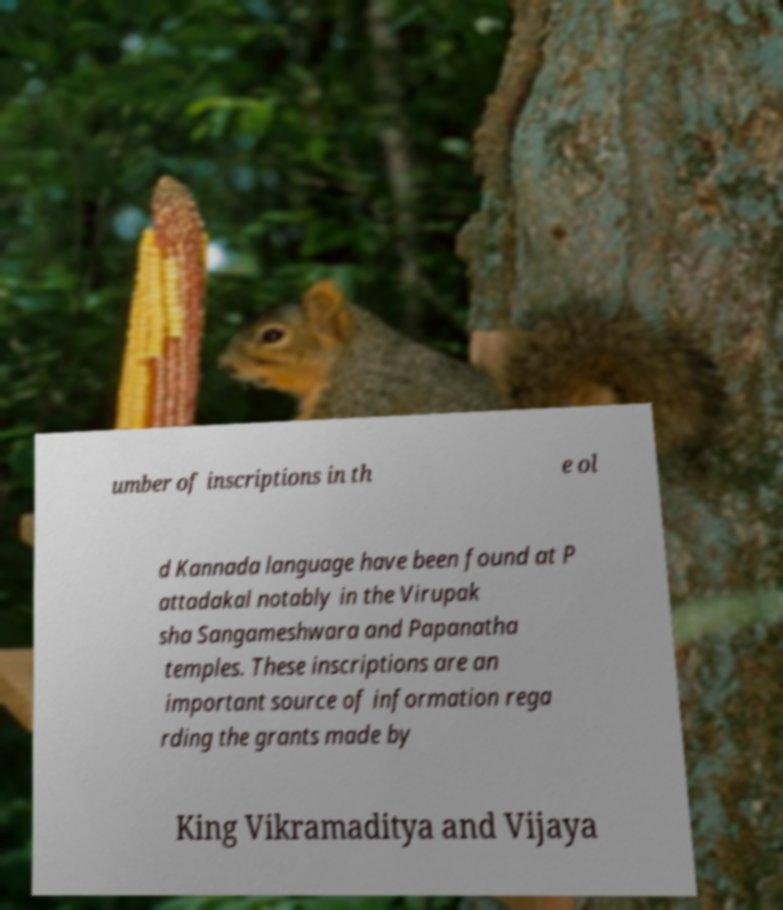Can you read and provide the text displayed in the image?This photo seems to have some interesting text. Can you extract and type it out for me? umber of inscriptions in th e ol d Kannada language have been found at P attadakal notably in the Virupak sha Sangameshwara and Papanatha temples. These inscriptions are an important source of information rega rding the grants made by King Vikramaditya and Vijaya 